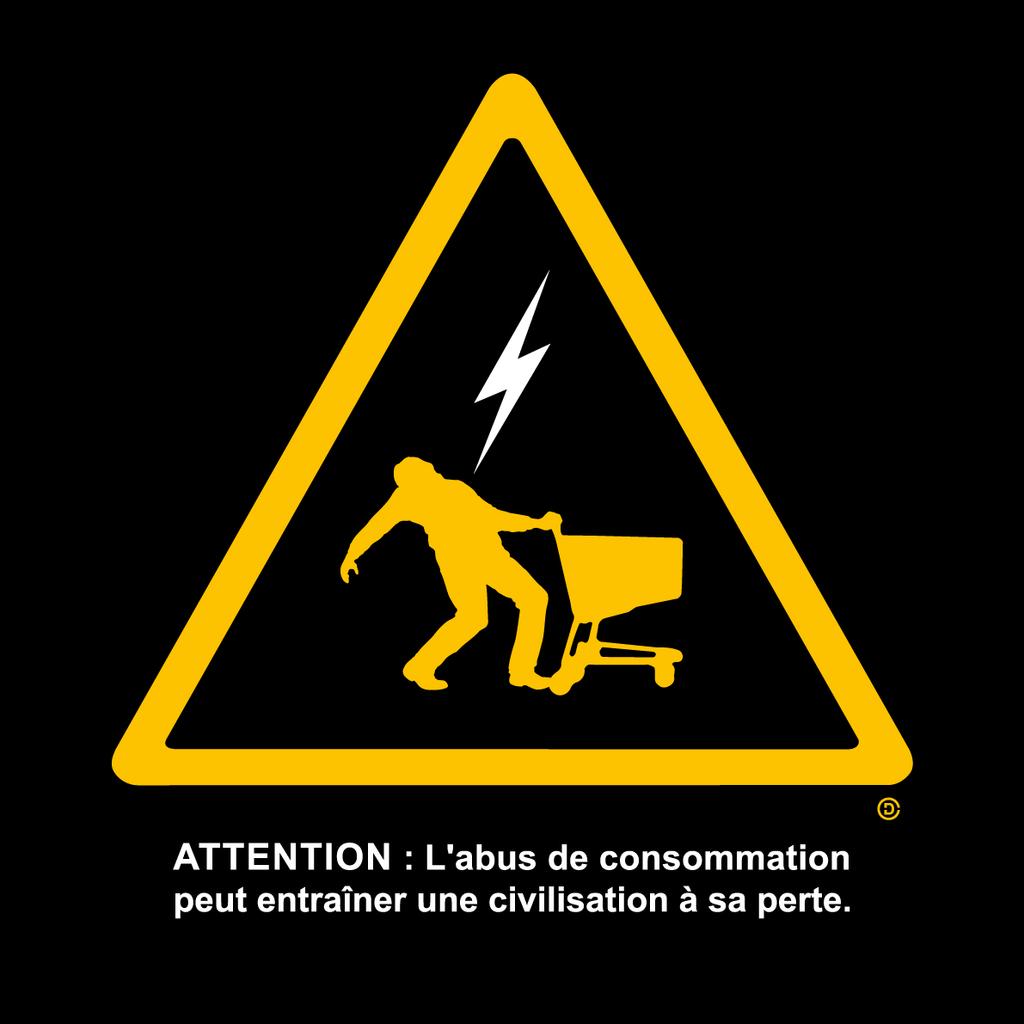What is the only word in english?
Keep it short and to the point. Attention. What does this sign ask for in the beginning?>?
Your response must be concise. Attention. 